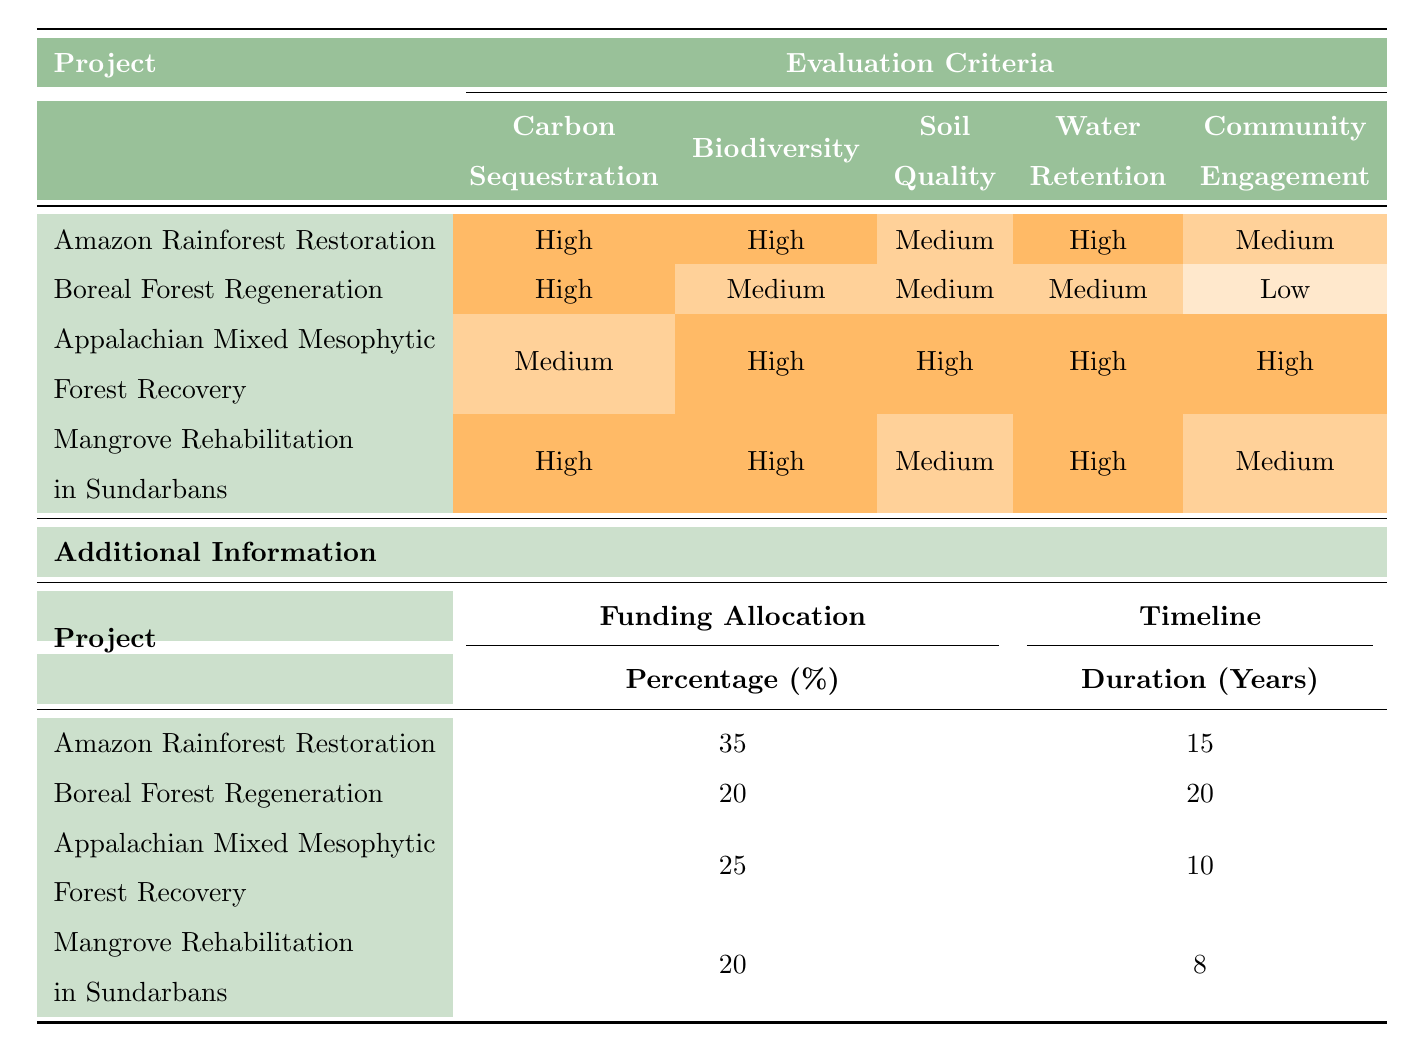What is the carbon sequestration potential of the Appalachian Mixed Mesophytic Forest Recovery project? The table indicates that the carbon sequestration potential for the Appalachian Mixed Mesophytic Forest Recovery project is rated as "Medium."
Answer: Medium Which project has the highest score for biodiversity enhancement? Referring to the table, both the Amazon Rainforest Restoration and Mangrove Rehabilitation in Sundarbans projects are rated "High" for biodiversity enhancement, indicating they are the top scorers in this criterion.
Answer: Amazon Rainforest Restoration, Mangrove Rehabilitation in Sundarbans What is the funding allocation percentage for the Boreal Forest Regeneration project? The table specifies that the funding allocation for the Boreal Forest Regeneration project is 20%.
Answer: 20% Is the soil quality rated higher for the Mangrove Rehabilitation in Sundarbans project compared to the Boreal Forest Regeneration project? The table shows that Mangrove Rehabilitation in Sundarbans has a soil quality rating of "Medium," while Boreal Forest Regeneration also has a soil quality rating of "Medium." Since they are equal, the answer is no.
Answer: No What is the total duration in years for projects with high carbon sequestration potential? The projects with high carbon sequestration potential are Amazon Rainforest Restoration, Boreal Forest Regeneration, and Mangrove Rehabilitation in Sundarbans, with respective durations of 15, 20, and 8 years. Summing these gives 15 + 20 + 8 = 43 years.
Answer: 43 How does the community engagement rating compare between Appalachian Mixed Mesophytic Forest Recovery and Boreal Forest Regeneration? The table indicates that the community engagement for Appalachian Mixed Mesophytic Forest Recovery is "High," while for Boreal Forest Regeneration, it is "Low." Therefore, Appalachian Mixed Mesophytic Forest Recovery has a significantly higher rating.
Answer: Higher What is the average funding allocation percentage for the projects evaluated? The funding allocation percentages are 35, 20, 25, and 20. To find the average, we sum these percentages: 35 + 20 + 25 + 20 = 100, then divide by the number of projects (4). Thus, 100 / 4 = 25.
Answer: 25 Which project has the shortest timeline? The table lists the durations of all projects, with Mangrove Rehabilitation in Sundarbans having the shortest timeline of 8 years compared to other projects.
Answer: Mangrove Rehabilitation in Sundarbans Is there a project that scores high in both water retention capacity and biodiversity enhancement? The table shows that both the Amazon Rainforest Restoration and Mangrove Rehabilitation in Sundarbans project have a high rating for water retention and biodiversity. Thus, yes, both projects meet this criterion.
Answer: Yes 